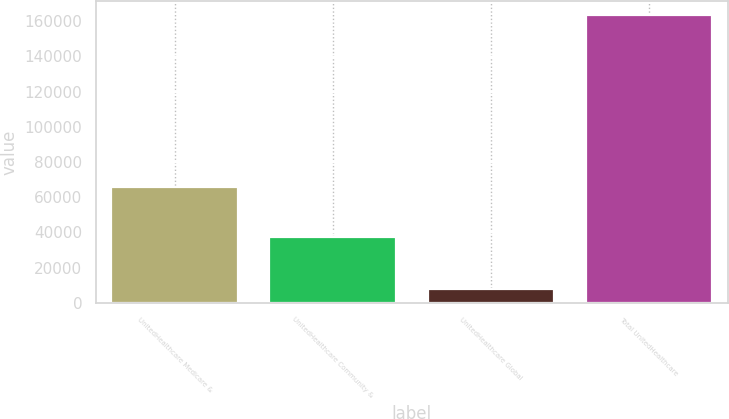<chart> <loc_0><loc_0><loc_500><loc_500><bar_chart><fcel>UnitedHealthcare Medicare &<fcel>UnitedHealthcare Community &<fcel>UnitedHealthcare Global<fcel>Total UnitedHealthcare<nl><fcel>65995<fcel>37443<fcel>7753<fcel>163257<nl></chart> 